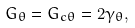<formula> <loc_0><loc_0><loc_500><loc_500>G _ { \theta } = G _ { c \theta } = 2 \gamma _ { \theta } ,</formula> 